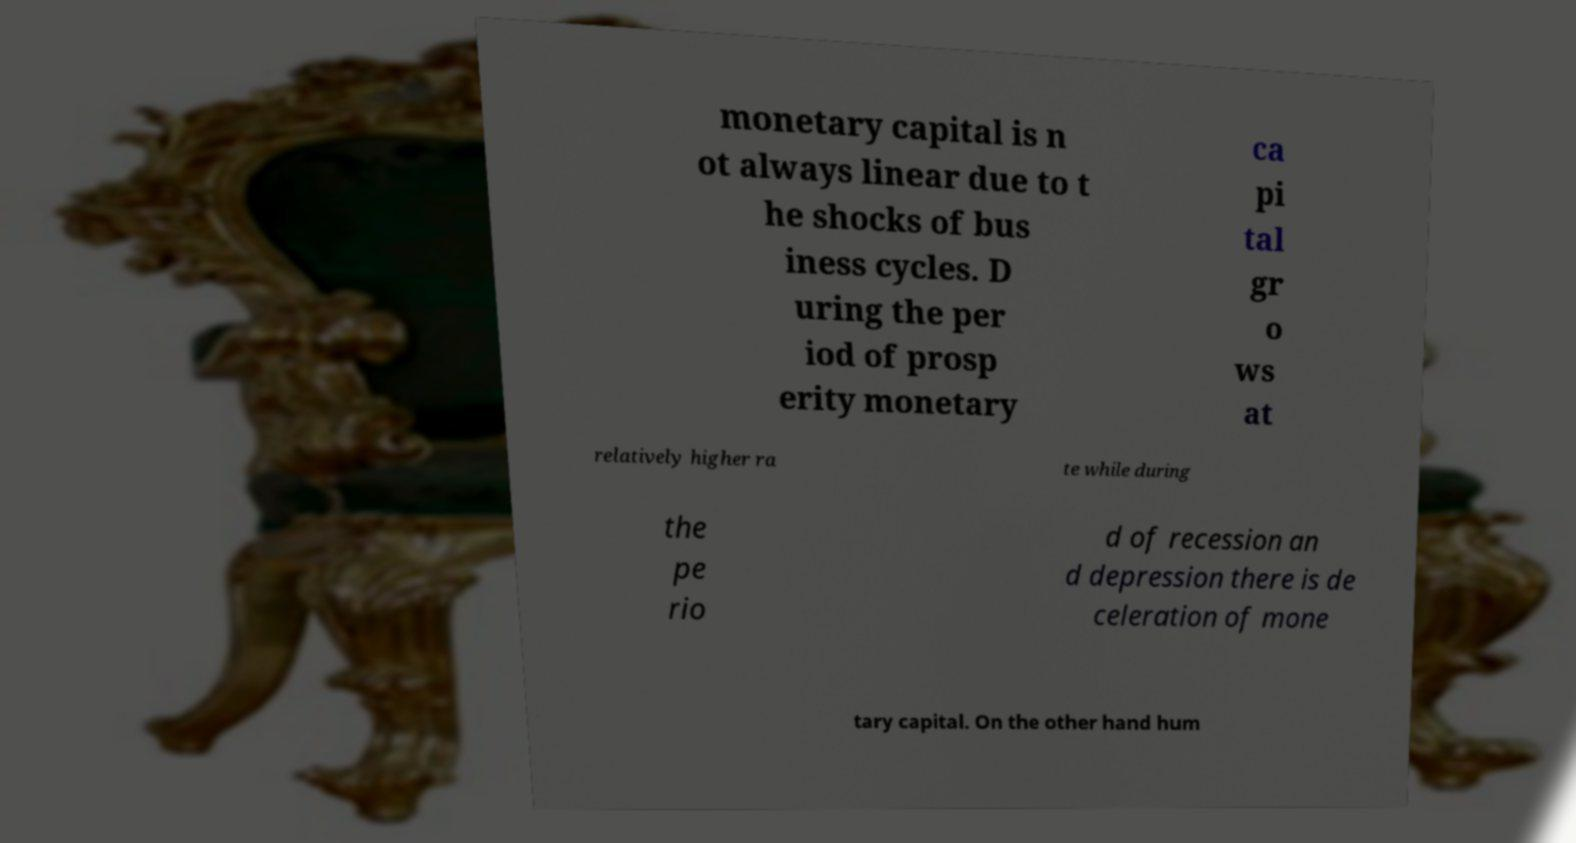Please identify and transcribe the text found in this image. monetary capital is n ot always linear due to t he shocks of bus iness cycles. D uring the per iod of prosp erity monetary ca pi tal gr o ws at relatively higher ra te while during the pe rio d of recession an d depression there is de celeration of mone tary capital. On the other hand hum 